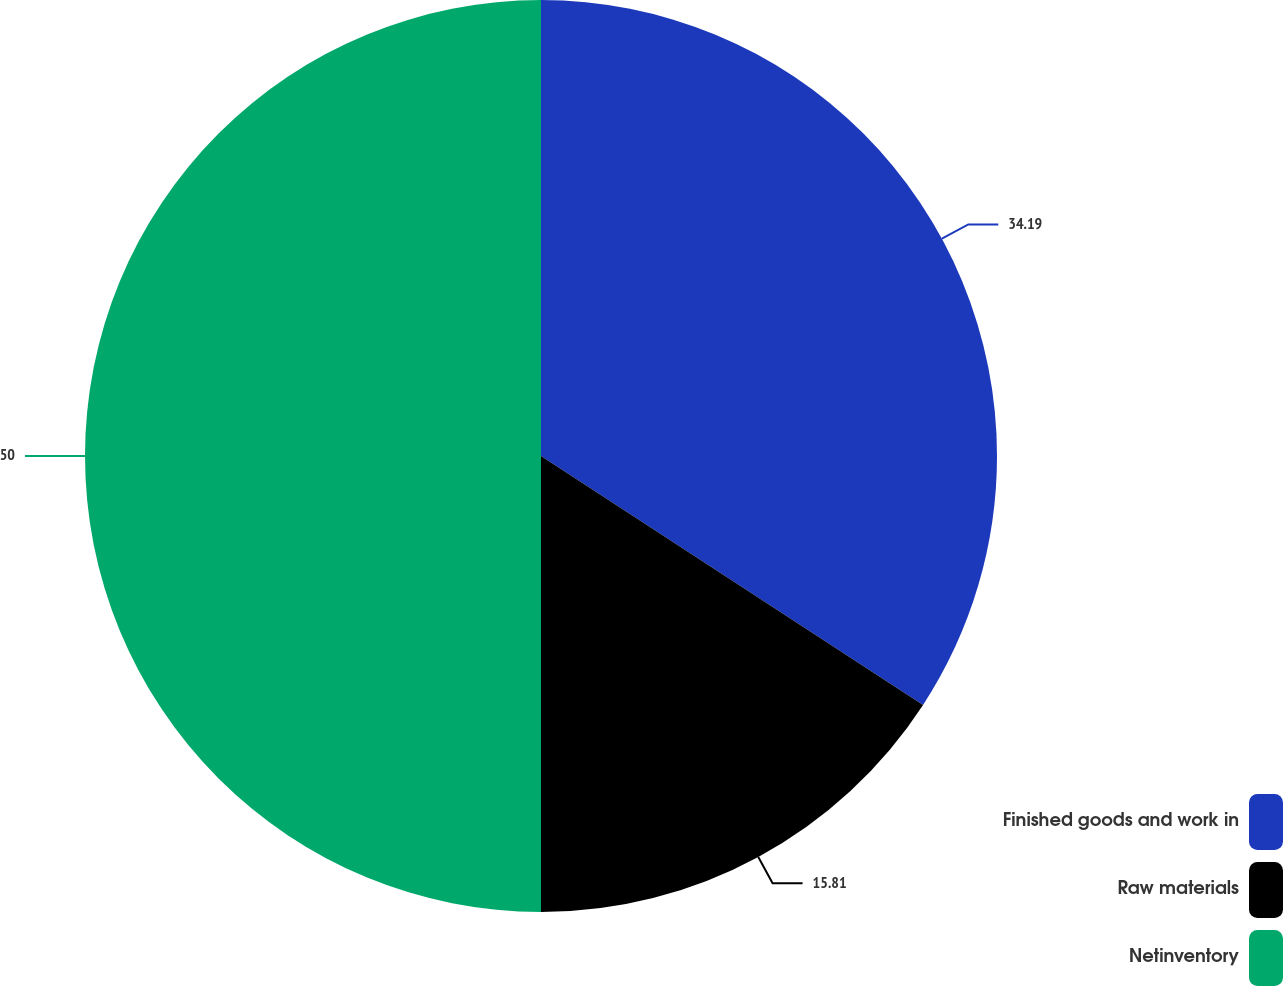Convert chart to OTSL. <chart><loc_0><loc_0><loc_500><loc_500><pie_chart><fcel>Finished goods and work in<fcel>Raw materials<fcel>Netinventory<nl><fcel>34.19%<fcel>15.81%<fcel>50.0%<nl></chart> 